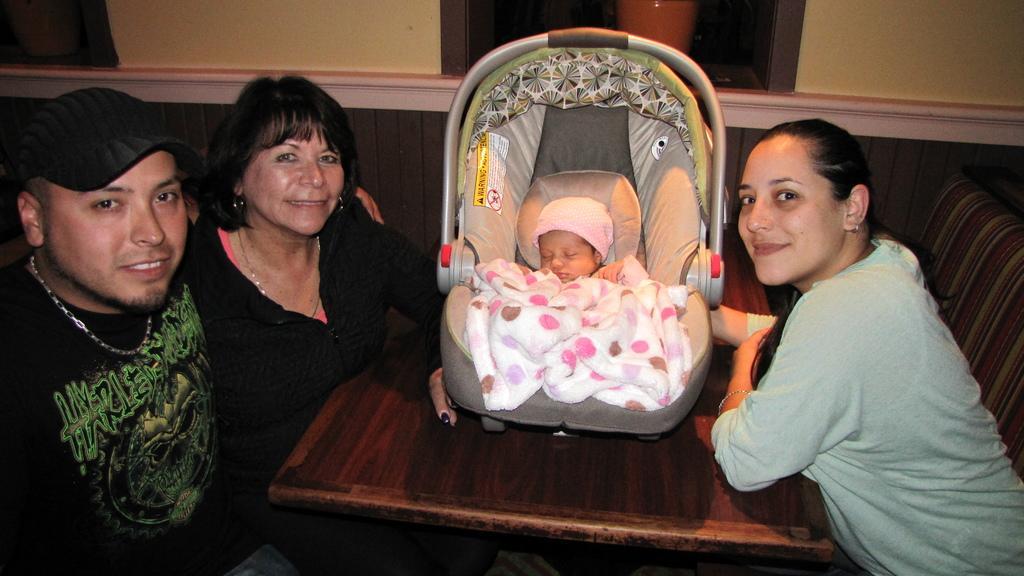In one or two sentences, can you explain what this image depicts? In this picture I can observe three people. All of them are smiling. In the middle of the picture there is a baby in the stroller. In the background I can observe wall. 